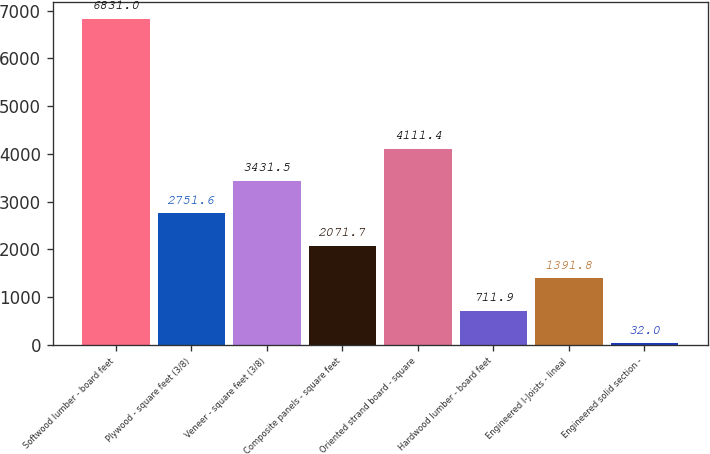Convert chart to OTSL. <chart><loc_0><loc_0><loc_500><loc_500><bar_chart><fcel>Softwood lumber - board feet<fcel>Plywood - square feet (3/8)<fcel>Veneer - square feet (3/8)<fcel>Composite panels - square feet<fcel>Oriented strand board - square<fcel>Hardwood lumber - board feet<fcel>Engineered I-Joists - lineal<fcel>Engineered solid section -<nl><fcel>6831<fcel>2751.6<fcel>3431.5<fcel>2071.7<fcel>4111.4<fcel>711.9<fcel>1391.8<fcel>32<nl></chart> 